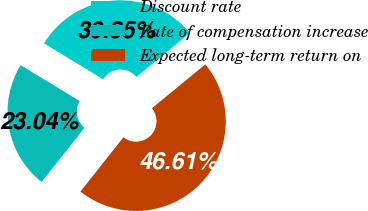Convert chart. <chart><loc_0><loc_0><loc_500><loc_500><pie_chart><fcel>Discount rate<fcel>Rate of compensation increase<fcel>Expected long-term return on<nl><fcel>30.35%<fcel>23.04%<fcel>46.61%<nl></chart> 